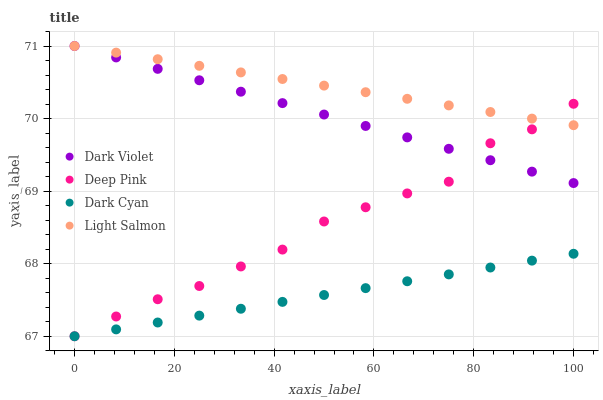Does Dark Cyan have the minimum area under the curve?
Answer yes or no. Yes. Does Light Salmon have the maximum area under the curve?
Answer yes or no. Yes. Does Deep Pink have the minimum area under the curve?
Answer yes or no. No. Does Deep Pink have the maximum area under the curve?
Answer yes or no. No. Is Light Salmon the smoothest?
Answer yes or no. Yes. Is Deep Pink the roughest?
Answer yes or no. Yes. Is Deep Pink the smoothest?
Answer yes or no. No. Is Light Salmon the roughest?
Answer yes or no. No. Does Dark Cyan have the lowest value?
Answer yes or no. Yes. Does Light Salmon have the lowest value?
Answer yes or no. No. Does Dark Violet have the highest value?
Answer yes or no. Yes. Does Deep Pink have the highest value?
Answer yes or no. No. Is Dark Cyan less than Light Salmon?
Answer yes or no. Yes. Is Dark Violet greater than Dark Cyan?
Answer yes or no. Yes. Does Dark Violet intersect Deep Pink?
Answer yes or no. Yes. Is Dark Violet less than Deep Pink?
Answer yes or no. No. Is Dark Violet greater than Deep Pink?
Answer yes or no. No. Does Dark Cyan intersect Light Salmon?
Answer yes or no. No. 